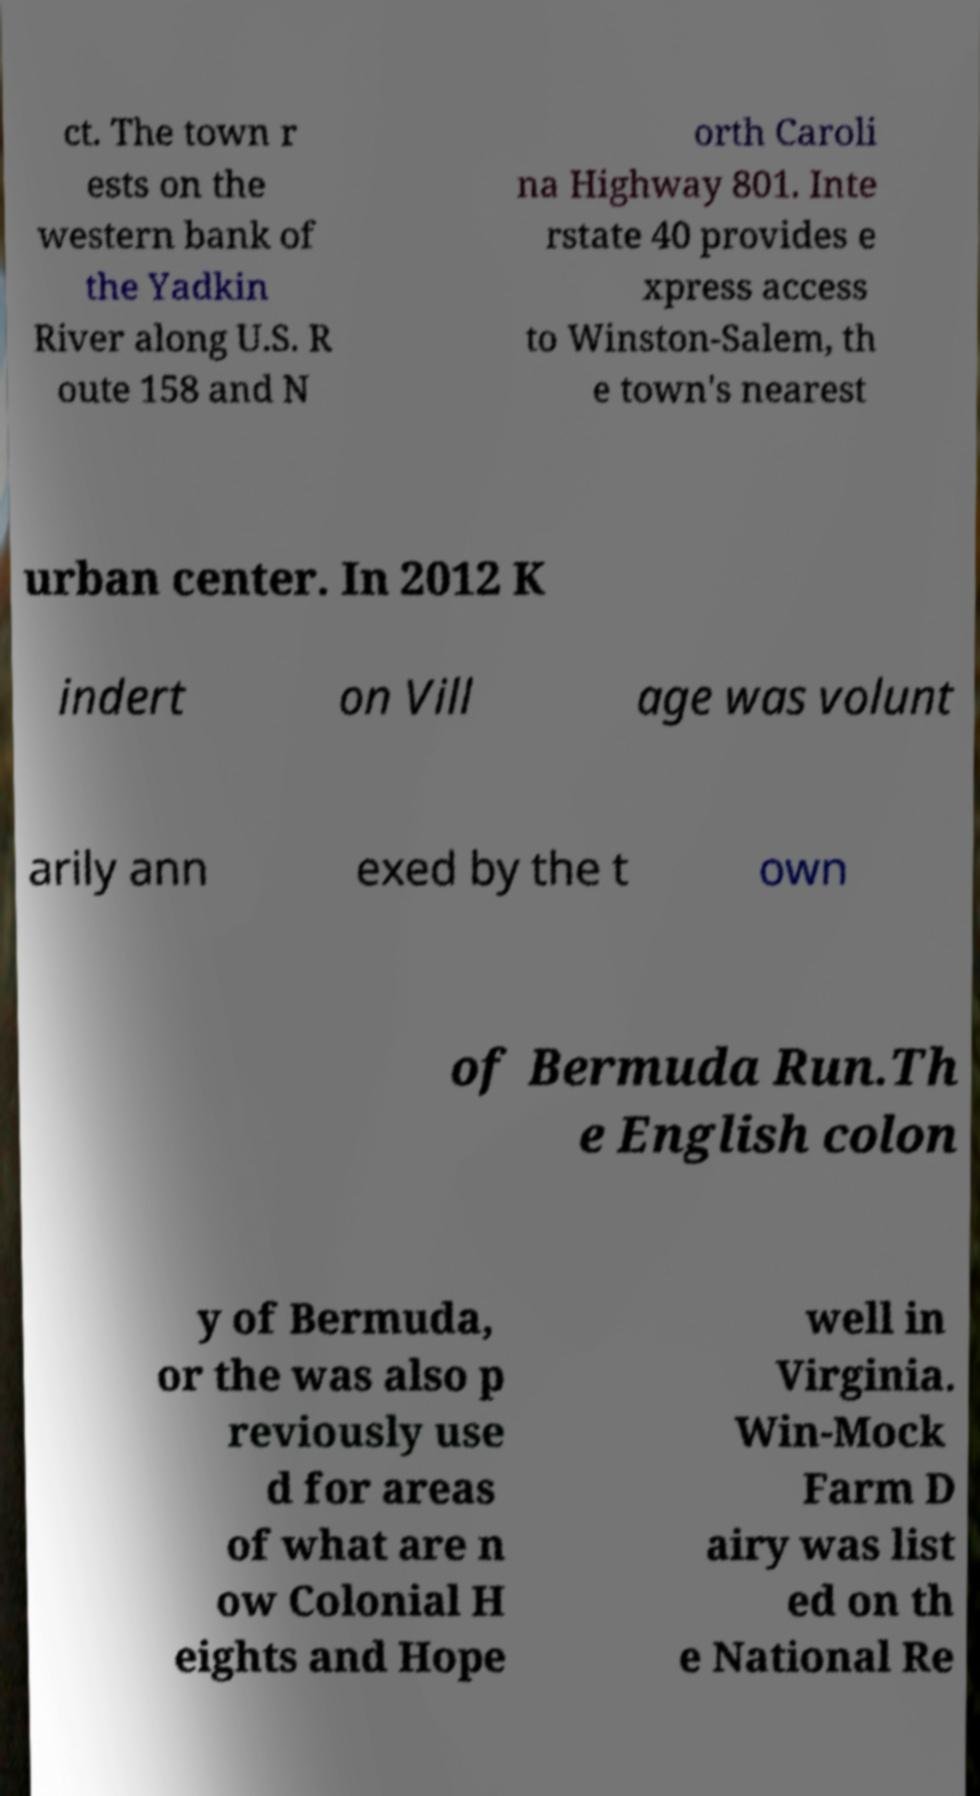Can you read and provide the text displayed in the image?This photo seems to have some interesting text. Can you extract and type it out for me? ct. The town r ests on the western bank of the Yadkin River along U.S. R oute 158 and N orth Caroli na Highway 801. Inte rstate 40 provides e xpress access to Winston-Salem, th e town's nearest urban center. In 2012 K indert on Vill age was volunt arily ann exed by the t own of Bermuda Run.Th e English colon y of Bermuda, or the was also p reviously use d for areas of what are n ow Colonial H eights and Hope well in Virginia. Win-Mock Farm D airy was list ed on th e National Re 